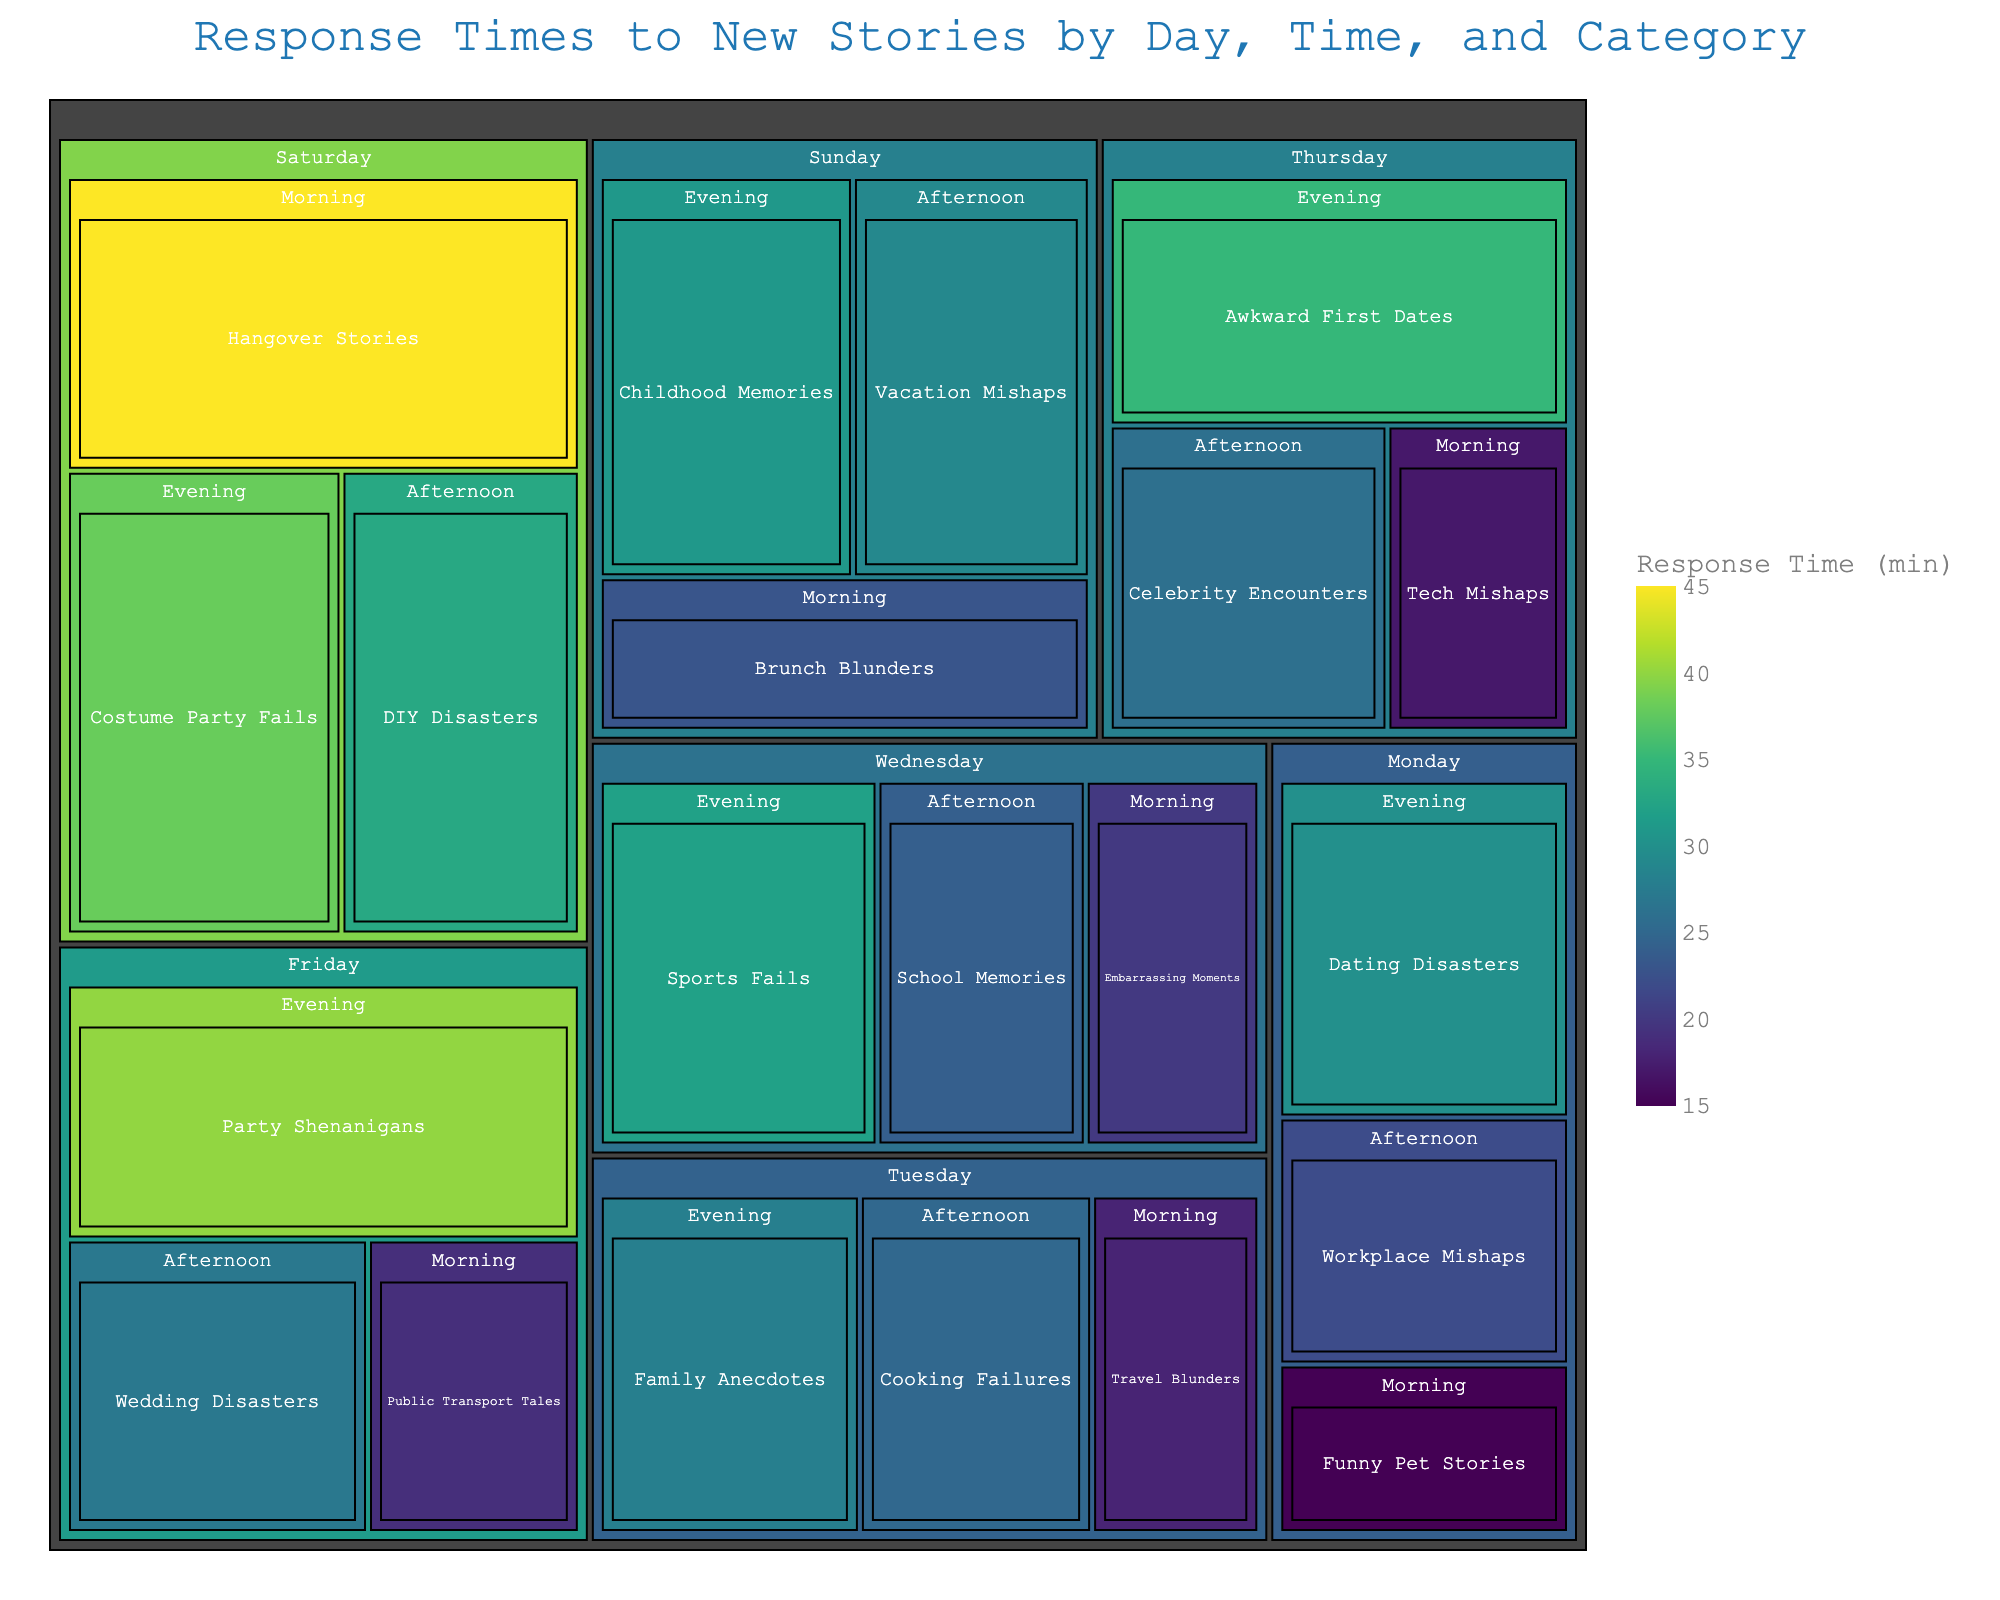What's the title of the figure? The title is typically found at the top of the figure. By reading this section, you can get an idea of what the data visualisation represents.
Answer: Response Times to New Stories by Day, Time, and Category What category of stories received the longest average response time? We need to look for the segment with the largest block and the darkest color, as these represent longer response times. Find the story category within this block.
Answer: Party Shenanigans Which day has the shortest average response time in the morning? To determine this, look at the morning segments for each day and identify the one with the smallest block and the lightest color, indicating the shortest response time.
Answer: Tech Mishaps on Thursday Is the response time generally higher in the mornings or evenings? Compare the average color intensity and block sizes of the morning segments to the evening segments across all days. Evening segments generally show darker colors and larger blocks than morning segments.
Answer: Evenings Comparing weekdays and weekends, which have higher average response times? Sum the total area and intensity of response times for weekdays (Monday to Friday) and compare them to weekends (Saturday and Sunday). Weekends will likely show higher average response times due to more darker and larger blocks.
Answer: Weekends Which category has the longest response time on Saturday morning? Look specifically at the Saturday morning block and spot the category with the largest area and the darkest color within that segment.
Answer: Hangover Stories What is the total response time for categories on Tuesday afternoon? Sum the response times for all categories within the Tuesday afternoon segment. Ensure you include each story's response time value from that segment.
Answer: 25 minutes Between Monday afternoon and Tuesday afternoon, which segment has a higher average response time? Compare the average intensity and block sizes of Monday afternoon and Tuesday afternoon segments. Calculate if necessary by taking the average of the response times listed.
Answer: Monday afternoon On which day do family anecdotes receive a response? Look through each day's segments until you find the one that contains the family anecdotes category.
Answer: Tuesday What time of day has the highest response time for 'Embarrassing Moments'? Identify the day and time block that includes the 'Embarrassing Moments' category and check its corresponding response time.
Answer: Wednesday morning 